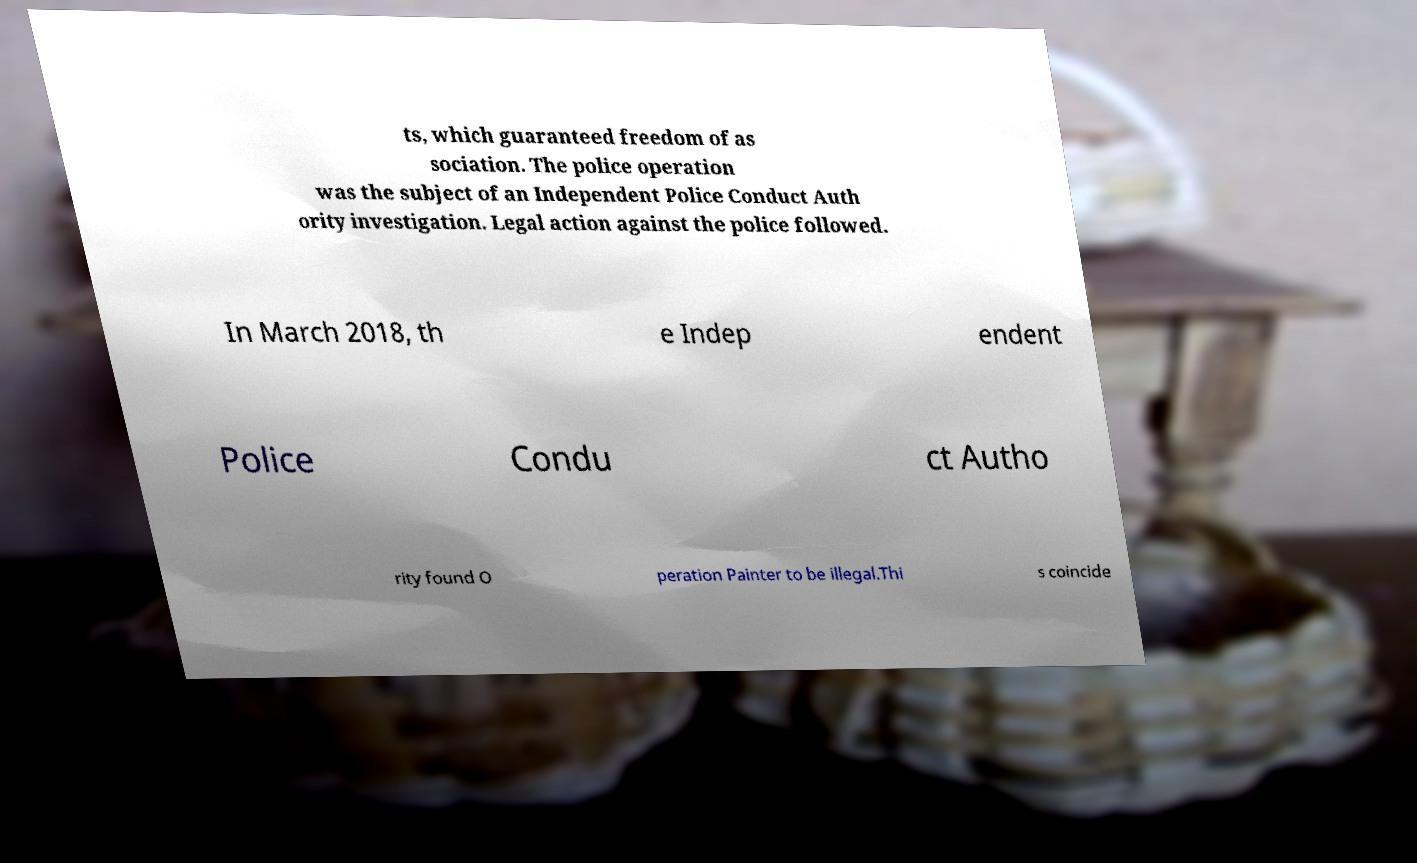Could you extract and type out the text from this image? ts, which guaranteed freedom of as sociation. The police operation was the subject of an Independent Police Conduct Auth ority investigation. Legal action against the police followed. In March 2018, th e Indep endent Police Condu ct Autho rity found O peration Painter to be illegal.Thi s coincide 